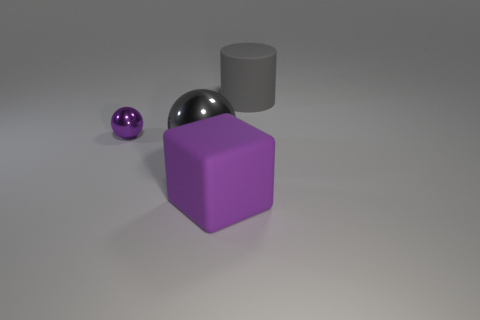How would you describe the lighting and mood of this scene? The lighting in the scene appears soft and diffused, with no harsh shadows, creating a calm and tranquil mood. The gentle lighting emphasizes the objects' colors and textures. 